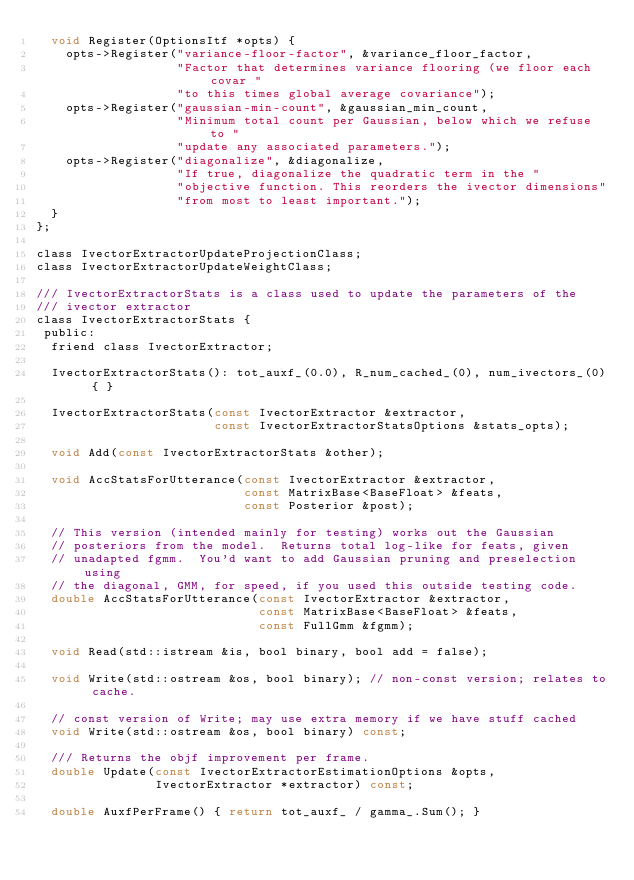<code> <loc_0><loc_0><loc_500><loc_500><_C_>  void Register(OptionsItf *opts) {
    opts->Register("variance-floor-factor", &variance_floor_factor,
                   "Factor that determines variance flooring (we floor each covar "
                   "to this times global average covariance");
    opts->Register("gaussian-min-count", &gaussian_min_count,
                   "Minimum total count per Gaussian, below which we refuse to "
                   "update any associated parameters.");
    opts->Register("diagonalize", &diagonalize, 
                   "If true, diagonalize the quadratic term in the "
                   "objective function. This reorders the ivector dimensions"
                   "from most to least important.");
  }
};

class IvectorExtractorUpdateProjectionClass;
class IvectorExtractorUpdateWeightClass;

/// IvectorExtractorStats is a class used to update the parameters of the
/// ivector extractor
class IvectorExtractorStats {
 public:
  friend class IvectorExtractor;

  IvectorExtractorStats(): tot_auxf_(0.0), R_num_cached_(0), num_ivectors_(0) { }
  
  IvectorExtractorStats(const IvectorExtractor &extractor,
                        const IvectorExtractorStatsOptions &stats_opts);
  
  void Add(const IvectorExtractorStats &other);
  
  void AccStatsForUtterance(const IvectorExtractor &extractor,
                            const MatrixBase<BaseFloat> &feats,
                            const Posterior &post);

  // This version (intended mainly for testing) works out the Gaussian
  // posteriors from the model.  Returns total log-like for feats, given
  // unadapted fgmm.  You'd want to add Gaussian pruning and preselection using
  // the diagonal, GMM, for speed, if you used this outside testing code.
  double AccStatsForUtterance(const IvectorExtractor &extractor,
                              const MatrixBase<BaseFloat> &feats,
                              const FullGmm &fgmm);
  
  void Read(std::istream &is, bool binary, bool add = false);

  void Write(std::ostream &os, bool binary); // non-const version; relates to cache.

  // const version of Write; may use extra memory if we have stuff cached
  void Write(std::ostream &os, bool binary) const; 

  /// Returns the objf improvement per frame.
  double Update(const IvectorExtractorEstimationOptions &opts,
                IvectorExtractor *extractor) const;

  double AuxfPerFrame() { return tot_auxf_ / gamma_.Sum(); }
</code> 